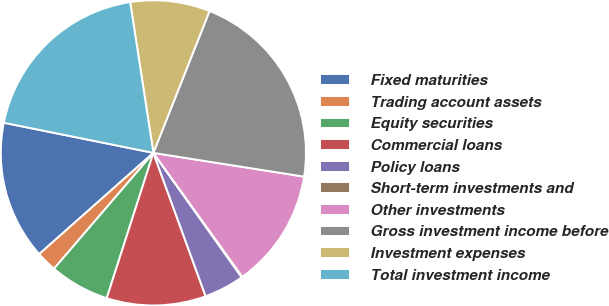<chart> <loc_0><loc_0><loc_500><loc_500><pie_chart><fcel>Fixed maturities<fcel>Trading account assets<fcel>Equity securities<fcel>Commercial loans<fcel>Policy loans<fcel>Short-term investments and<fcel>Other investments<fcel>Gross investment income before<fcel>Investment expenses<fcel>Total investment income<nl><fcel>14.71%<fcel>2.17%<fcel>6.34%<fcel>10.51%<fcel>4.26%<fcel>0.09%<fcel>12.6%<fcel>21.49%<fcel>8.43%<fcel>19.4%<nl></chart> 